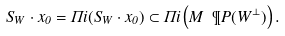<formula> <loc_0><loc_0><loc_500><loc_500>S _ { W } \cdot x _ { 0 } = \Pi i ( S _ { W } \cdot x _ { 0 } ) \subset \Pi i \left ( M \ \P P ( W ^ { \perp } ) \right ) .</formula> 